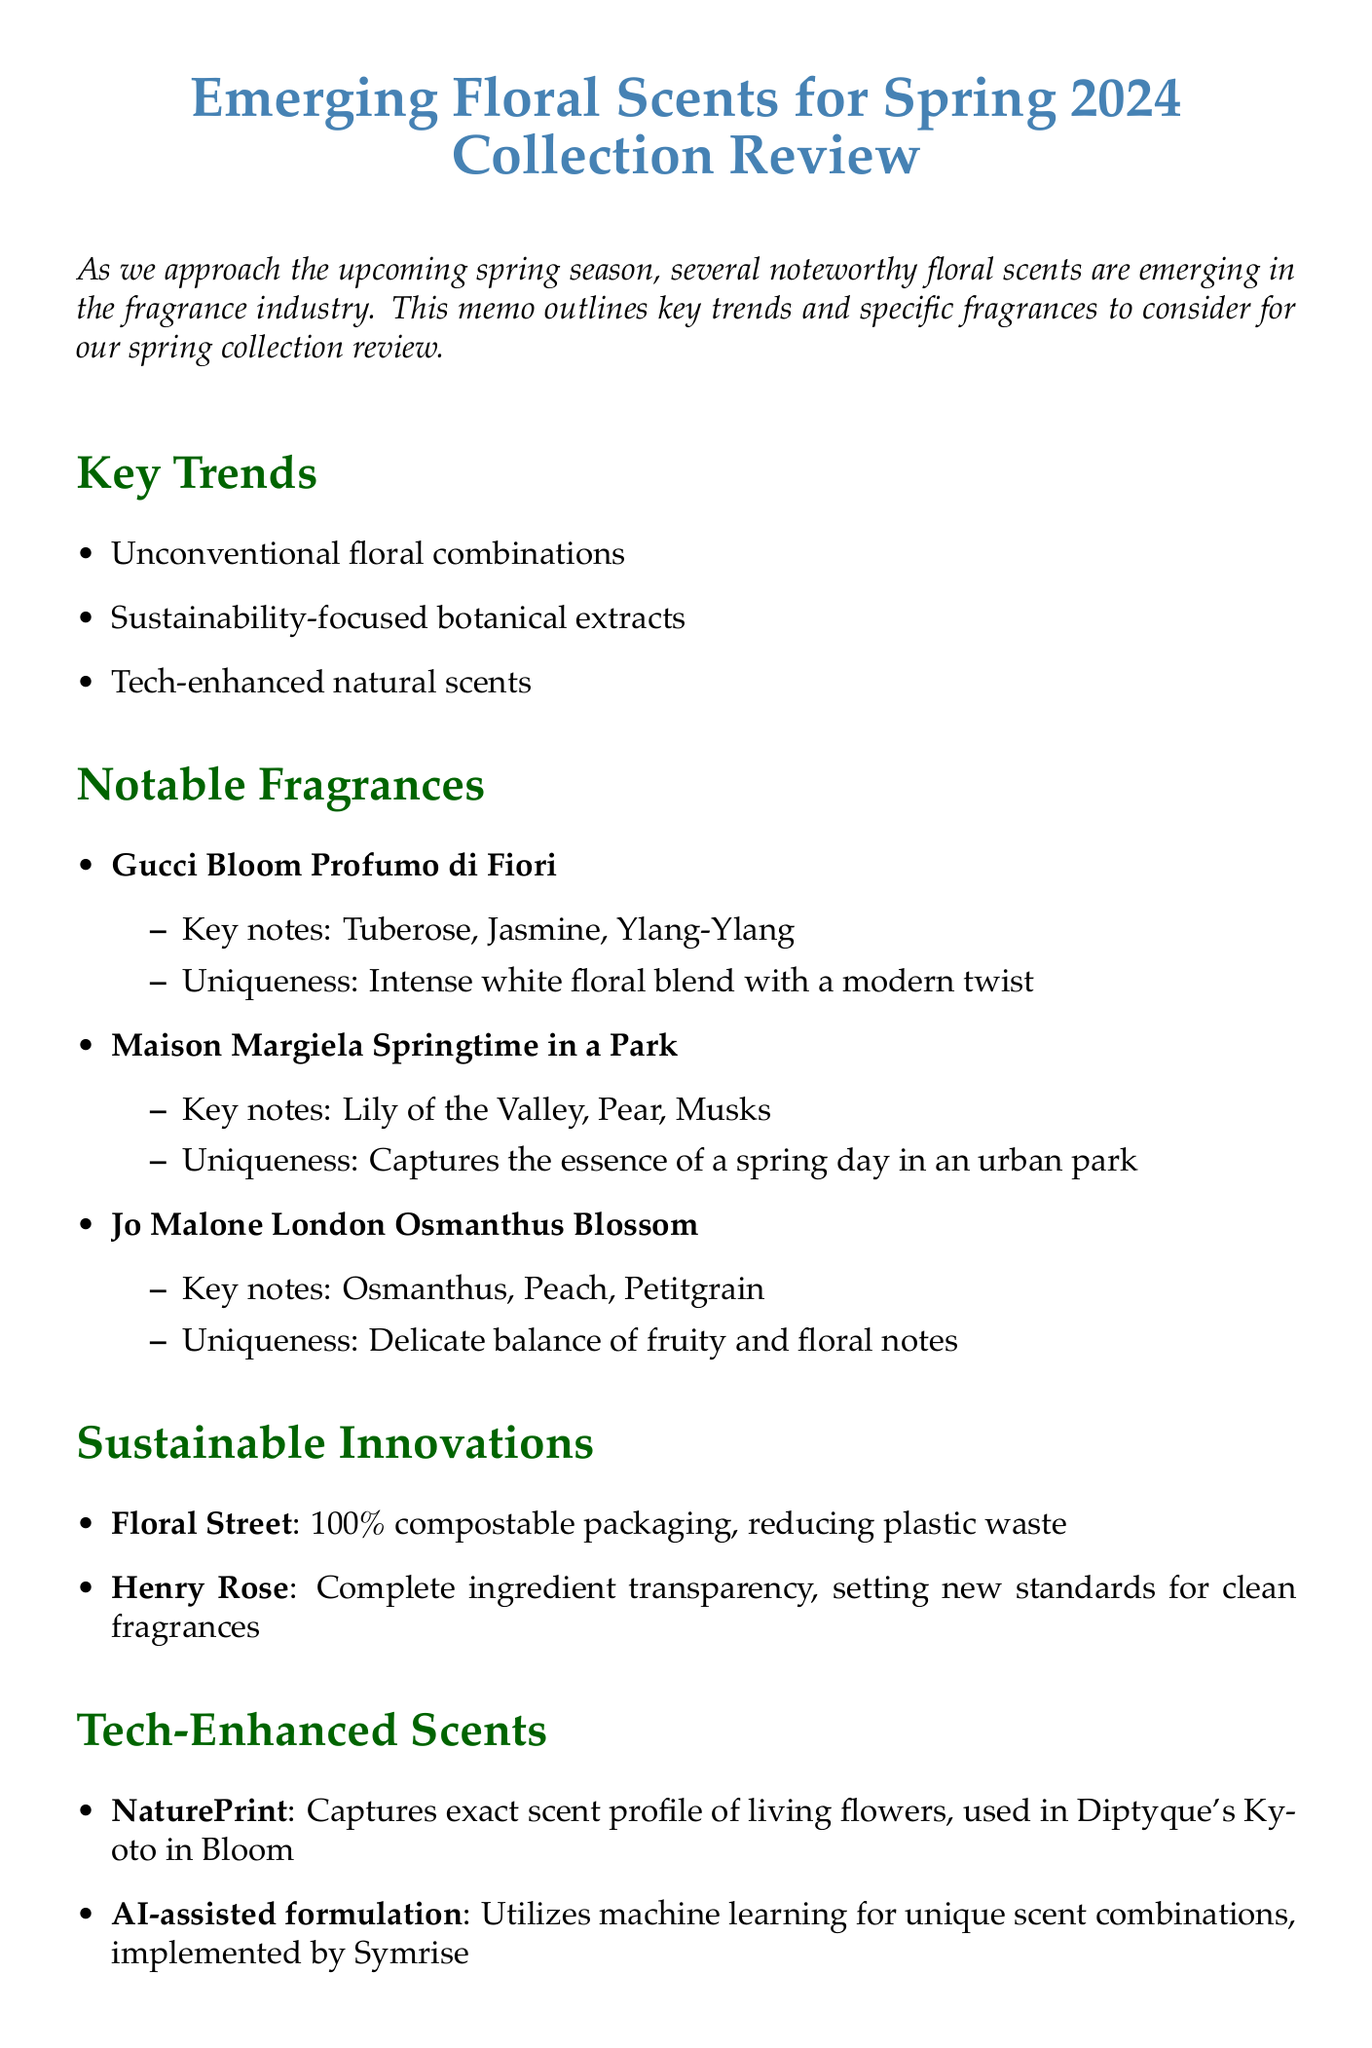What is the title of the memo? The title of the memo summarizes the main subject of the document, which is about emerging floral scents for the upcoming spring collection.
Answer: Emerging Floral Scents for Spring 2024 Collection Review What are the key trends mentioned in the memo? The key trends highlight important developments in floral scents, specifically pointing out innovations and directions in the fragrance industry.
Answer: Unconventional floral combinations, Sustainability-focused botanical extracts, Tech-enhanced natural scents Which fragrance features Tuberose as a key note? This question requires recalling specific fragrances and their descriptions as listed in the notable fragrances section.
Answer: Gucci Bloom Profumo di Fiori What innovative packaging solution is mentioned? The sustainable innovations section describes how certain brands are addressing environmental concerns through new packaging initiatives.
Answer: 100% compostable packaging What technology captures the exact scent profile of living flowers? This is regarding the technological advancements in fragrance development as outlined in the tech-enhanced scents section of the memo.
Answer: NaturePrint Which brand is known for its complete ingredient transparency? This question focuses on the sustainable innovations highlighted in the document, aiming to identify brands leading in transparency.
Answer: Henry Rose What is the uniqueness of "Maison Margiela Springtime in a Park"? The uniqueness describes what sets the fragrance apart in terms of its scent profile or olfactory experience.
Answer: Captures the essence of a spring day in an urban park How many fragrances are listed in the notable fragrances section? This requires adding the fragrance names provided within the notable fragrances list to obtain the total count.
Answer: Three What does the AI-assisted formulation use for creating unique scents? This question relates to the technology used in fragrance formulation as described under tech-enhanced scents.
Answer: Machine learning 